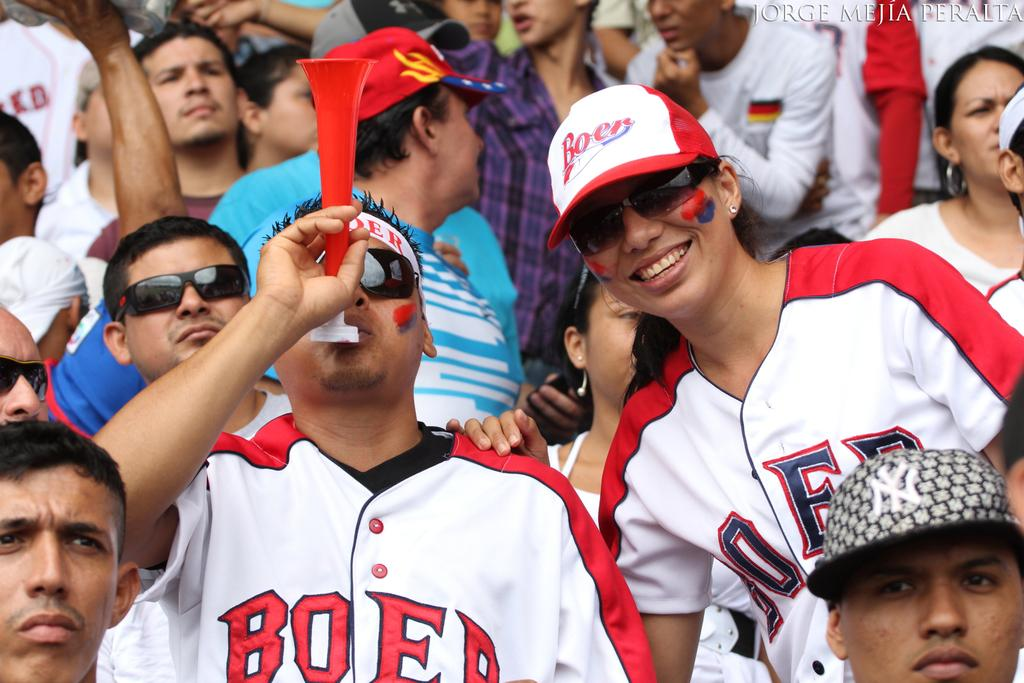Provide a one-sentence caption for the provided image. man wearing boer jersey blowing horn as woman stands next to him. 